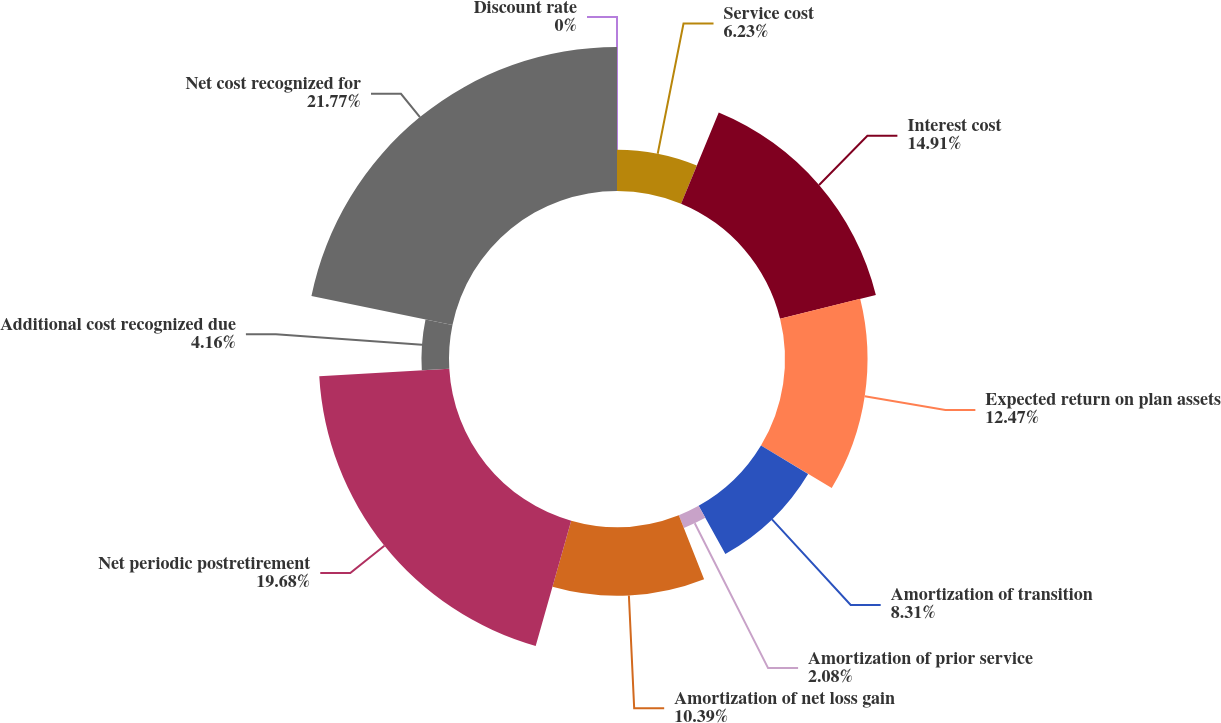Convert chart. <chart><loc_0><loc_0><loc_500><loc_500><pie_chart><fcel>Service cost<fcel>Interest cost<fcel>Expected return on plan assets<fcel>Amortization of transition<fcel>Amortization of prior service<fcel>Amortization of net loss gain<fcel>Net periodic postretirement<fcel>Additional cost recognized due<fcel>Net cost recognized for<fcel>Discount rate<nl><fcel>6.23%<fcel>14.91%<fcel>12.47%<fcel>8.31%<fcel>2.08%<fcel>10.39%<fcel>19.68%<fcel>4.16%<fcel>21.76%<fcel>0.0%<nl></chart> 